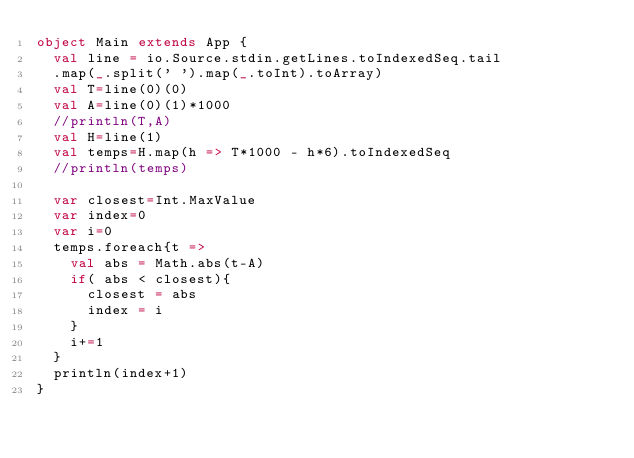Convert code to text. <code><loc_0><loc_0><loc_500><loc_500><_Scala_>object Main extends App {
  val line = io.Source.stdin.getLines.toIndexedSeq.tail
  .map(_.split(' ').map(_.toInt).toArray)
  val T=line(0)(0)
  val A=line(0)(1)*1000
  //println(T,A)
  val H=line(1)
  val temps=H.map(h => T*1000 - h*6).toIndexedSeq
  //println(temps)
  
  var closest=Int.MaxValue
  var index=0
  var i=0
  temps.foreach{t =>
    val abs = Math.abs(t-A)
    if( abs < closest){
      closest = abs
      index = i
    }
    i+=1
  }
  println(index+1)
}
	</code> 